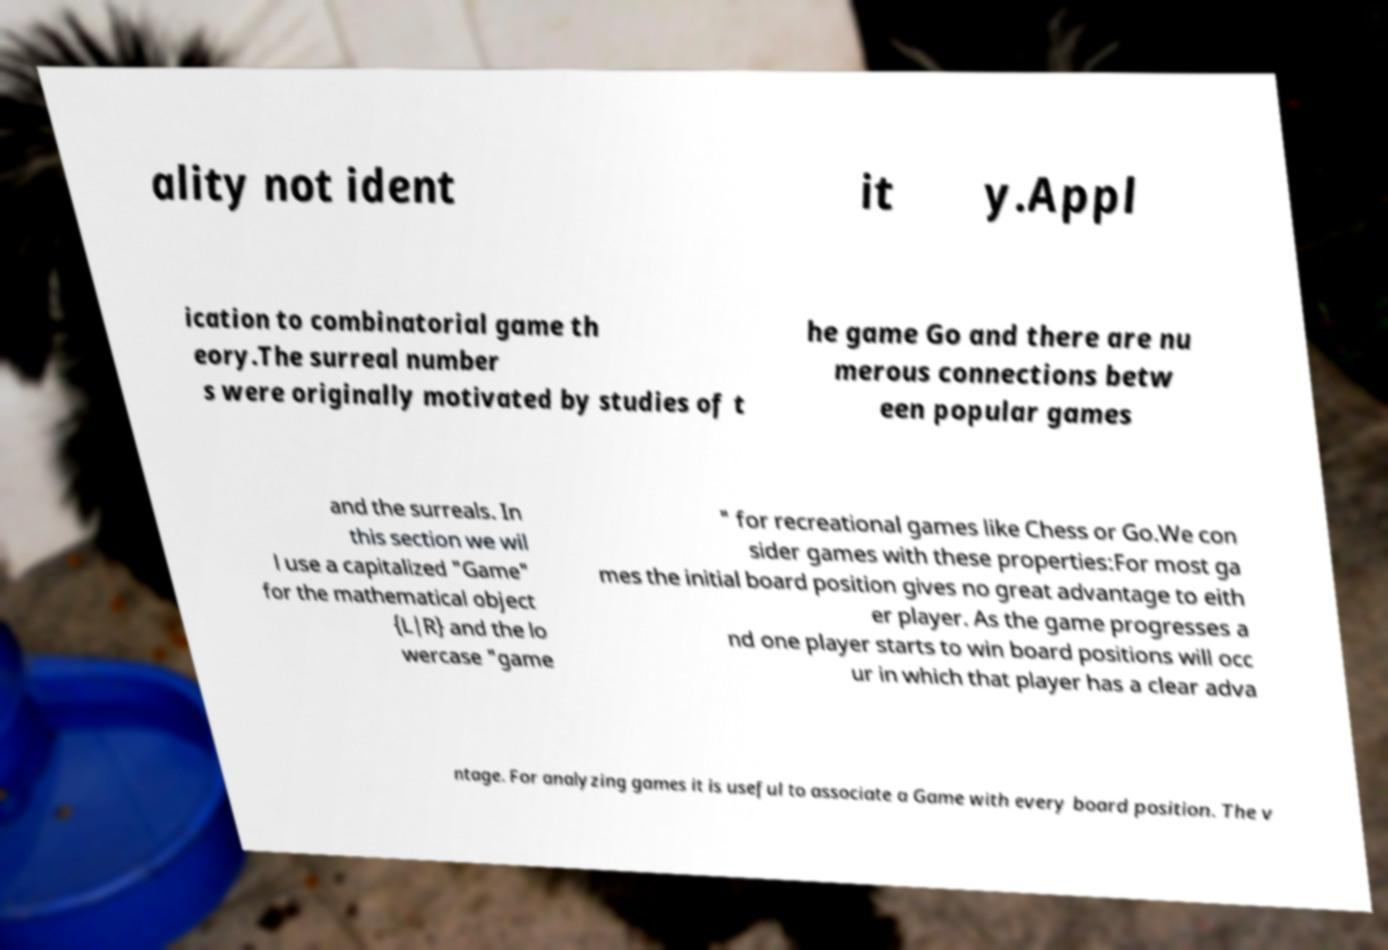What messages or text are displayed in this image? I need them in a readable, typed format. ality not ident it y.Appl ication to combinatorial game th eory.The surreal number s were originally motivated by studies of t he game Go and there are nu merous connections betw een popular games and the surreals. In this section we wil l use a capitalized "Game" for the mathematical object {L|R} and the lo wercase "game " for recreational games like Chess or Go.We con sider games with these properties:For most ga mes the initial board position gives no great advantage to eith er player. As the game progresses a nd one player starts to win board positions will occ ur in which that player has a clear adva ntage. For analyzing games it is useful to associate a Game with every board position. The v 